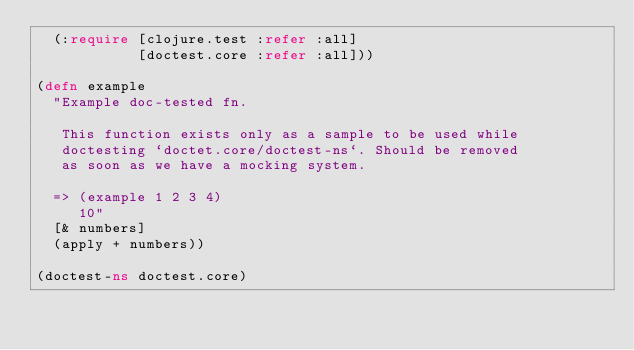Convert code to text. <code><loc_0><loc_0><loc_500><loc_500><_Clojure_>  (:require [clojure.test :refer :all]
            [doctest.core :refer :all]))

(defn example
  "Example doc-tested fn.

   This function exists only as a sample to be used while
   doctesting `doctet.core/doctest-ns`. Should be removed
   as soon as we have a mocking system.

  => (example 1 2 3 4)
     10"
  [& numbers]
  (apply + numbers))

(doctest-ns doctest.core)
</code> 